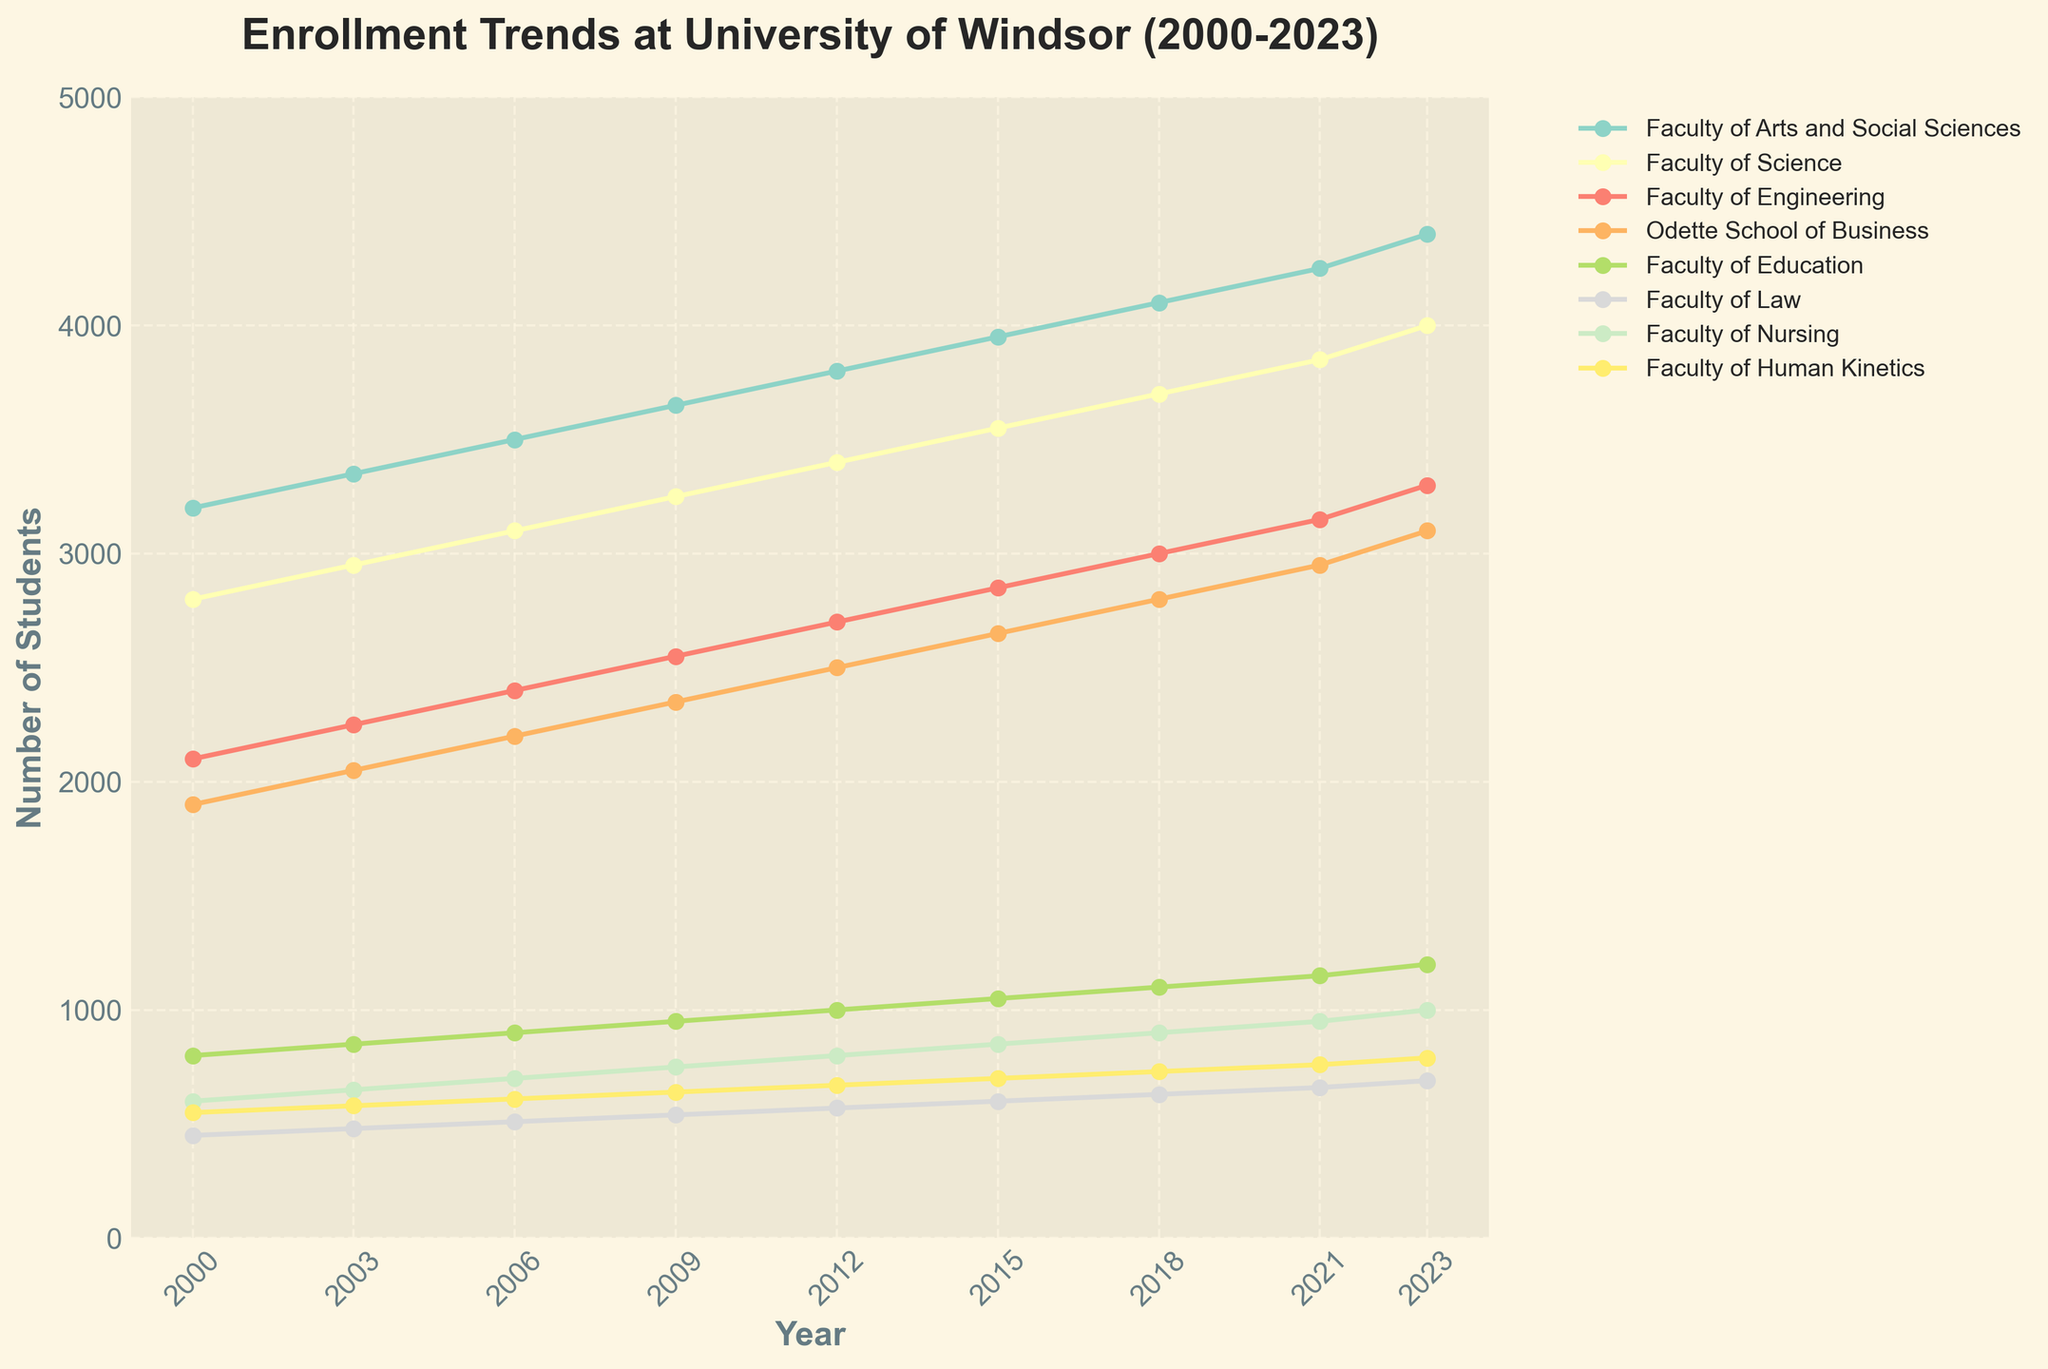What is the trend in enrollment for the Faculty of Engineering from 2000 to 2023? The enrollment for the Faculty of Engineering shows a clear increasing trend over time. Starting from 2100 in 2000, it rose steadily every three years, reaching 3300 by 2023.
Answer: Increasing Which faculty had the highest enrollment in 2023? By looking at the data points for the year 2023, the Faculty of Arts and Social Sciences had the highest enrollment with 4400 students.
Answer: Faculty of Arts and Social Sciences How many students were enrolled in the Faculty of Law in 2009 compared to the Faculty of Nursing? According to the data for 2009, the Faculty of Law had 540 students while the Faculty of Nursing had 750 students.
Answer: Faculty of Nursing had more students Which year did the Faculty of Human Kinetics have an enrollment of 670 students? Examining the data points, the Faculty of Human Kinetics had 670 students enrolled in 2012.
Answer: 2012 What was the average enrollment in the Odette School of Business from 2000 to 2023? To find the average, we add the enrollments for each year and divide by the number of years. (1900 + 2050 + 2200 + 2350 + 2500 + 2650 + 2800 + 2950 + 3100) / 9 = 2478
Answer: 2478 How did the enrollment in the Faculty of Science change between 2015 and 2021? From the data, the enrollment in the Faculty of Science increased from 3550 in 2015 to 3850 in 2021.
Answer: Increased Compare the number of students in the Faculty of Education and the Faculty of Law in 2023. In 2023, the Faculty of Education had 1200 students, whereas the Faculty of Law had 690 students. Thus, the Faculty of Education had significantly more students.
Answer: Faculty of Education had more What is the gap between the highest enrollment and the lowest enrollment in 2023? To find the gap, we identify the highest enrollment (4400 in the Faculty of Arts and Social Sciences) and the lowest enrollment (690 in the Faculty of Law), and subtract them: 4400 - 690 = 3710.
Answer: 3710 Which faculty witnessed the smallest change in enrollment from 2000 to 2023? The Faculty of Law had the smallest change. Its enrollment changed from 450 in 2000 to 690 in 2023, increasing by only 240 students.
Answer: Faculty of Law 